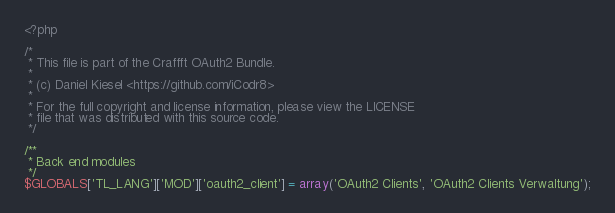Convert code to text. <code><loc_0><loc_0><loc_500><loc_500><_PHP_><?php

/*
 * This file is part of the Craffft OAuth2 Bundle.
 *
 * (c) Daniel Kiesel <https://github.com/iCodr8>
 *
 * For the full copyright and license information, please view the LICENSE
 * file that was distributed with this source code.
 */

/**
 * Back end modules
 */
$GLOBALS['TL_LANG']['MOD']['oauth2_client'] = array('OAuth2 Clients', 'OAuth2 Clients Verwaltung');
</code> 